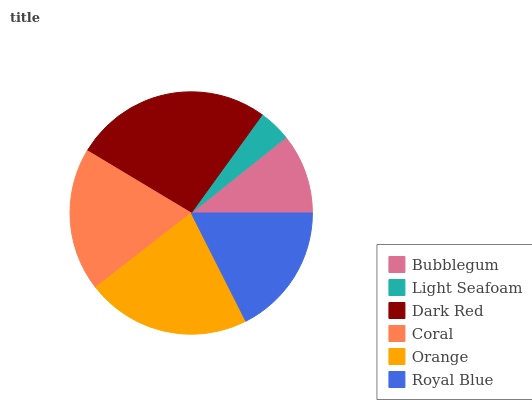Is Light Seafoam the minimum?
Answer yes or no. Yes. Is Dark Red the maximum?
Answer yes or no. Yes. Is Dark Red the minimum?
Answer yes or no. No. Is Light Seafoam the maximum?
Answer yes or no. No. Is Dark Red greater than Light Seafoam?
Answer yes or no. Yes. Is Light Seafoam less than Dark Red?
Answer yes or no. Yes. Is Light Seafoam greater than Dark Red?
Answer yes or no. No. Is Dark Red less than Light Seafoam?
Answer yes or no. No. Is Coral the high median?
Answer yes or no. Yes. Is Royal Blue the low median?
Answer yes or no. Yes. Is Orange the high median?
Answer yes or no. No. Is Light Seafoam the low median?
Answer yes or no. No. 